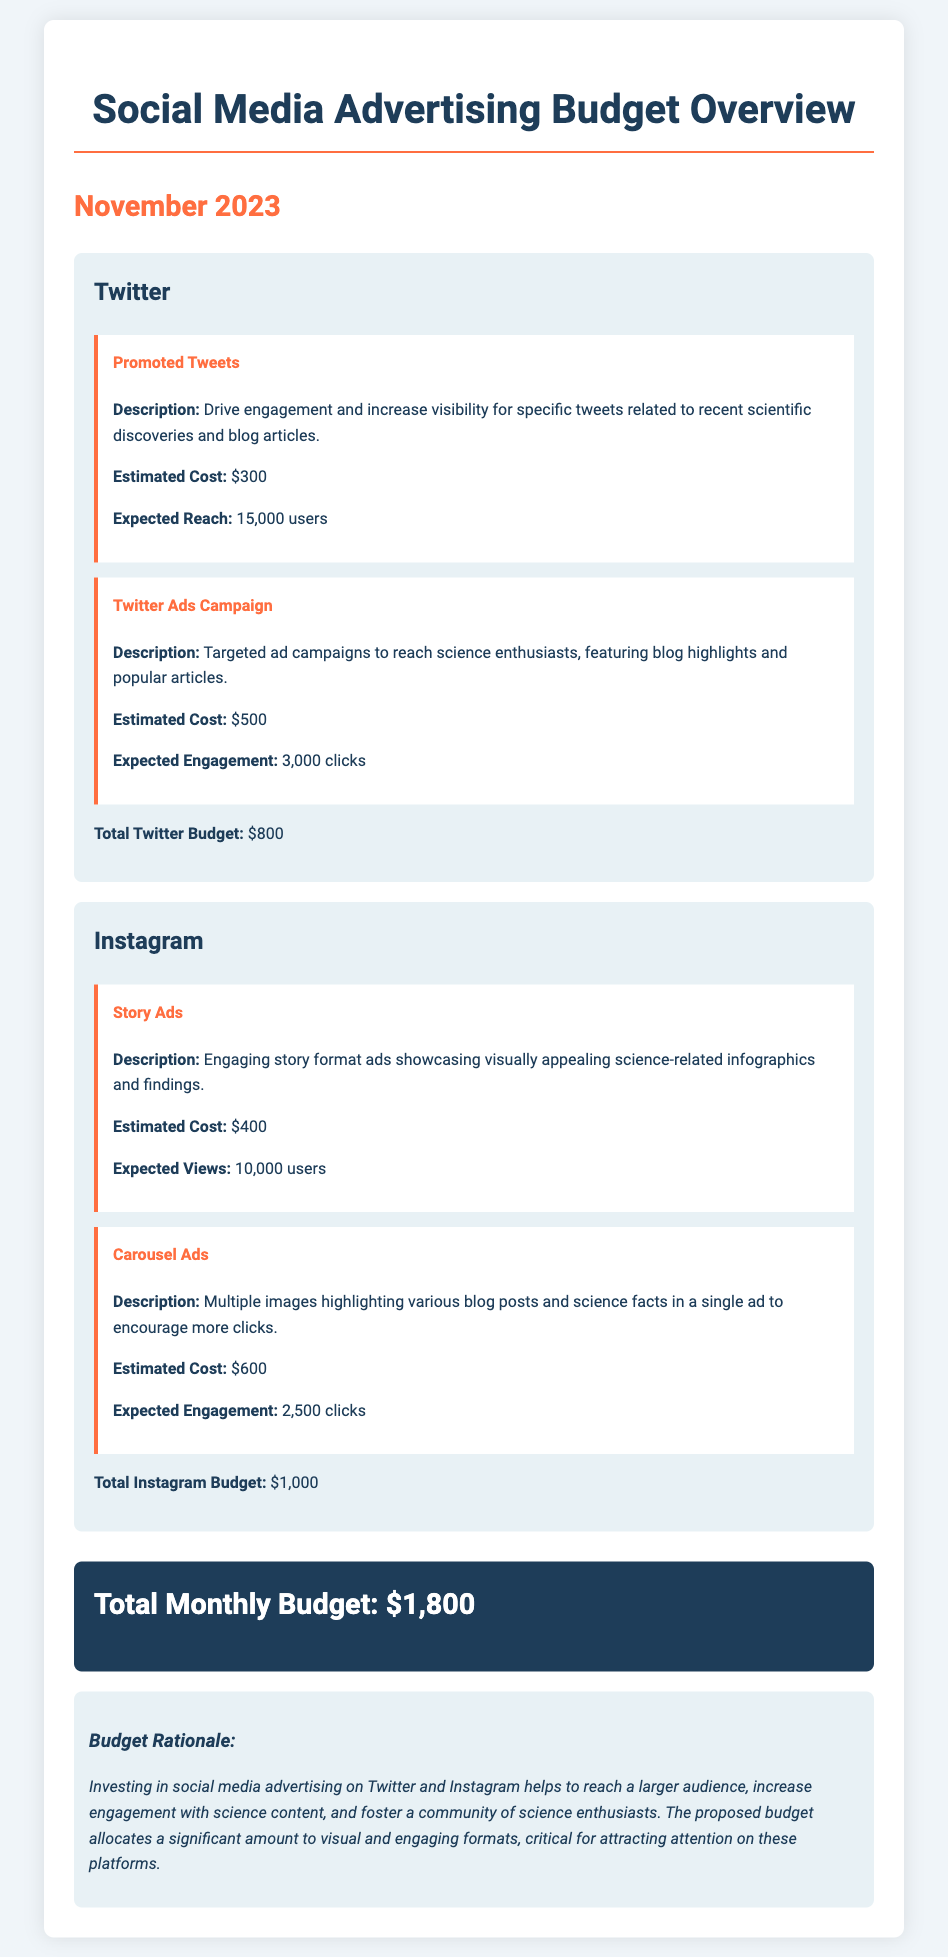What is the total Twitter budget? The total Twitter budget is mentioned at the end of the Twitter section, which is $800.
Answer: $800 What is the estimated cost for Carousel Ads on Instagram? The estimated cost for Carousel Ads is provided under the Instagram section, which is $600.
Answer: $600 How many expected views are there for Story Ads on Instagram? The expected views for Story Ads are detailed in the Instagram section, which states 10,000 users.
Answer: 10,000 users What is the total monthly budget for November 2023? The total monthly budget is summarized in the budget summary section, which is $1,800.
Answer: $1,800 What type of content is targeted by the Twitter Ads Campaign? The type of content targeted by the Twitter Ads Campaign is highlighted in the description, which includes blog highlights and popular articles.
Answer: Blog highlights and popular articles How much is allocated for Promoted Tweets on Twitter? The allocated budget for Promoted Tweets is provided in the Twitter section, which is $300.
Answer: $300 What is the expected engagement for Instagram Carousel Ads? The expected engagement for Instagram Carousel Ads is specified in the Instagram section, which states 2,500 clicks.
Answer: 2,500 clicks What is the rationale for the budget allocation mentioned in the document? The rationale for the budget allocation discusses reaching a larger audience and increasing engagement with science content, which is key for attracting attention.
Answer: Reach a larger audience and increase engagement How many expected clicks from the Twitter Ads Campaign? The expected clicks from the Twitter Ads Campaign are detailed in the Twitter section, which states 3,000 clicks.
Answer: 3,000 clicks 